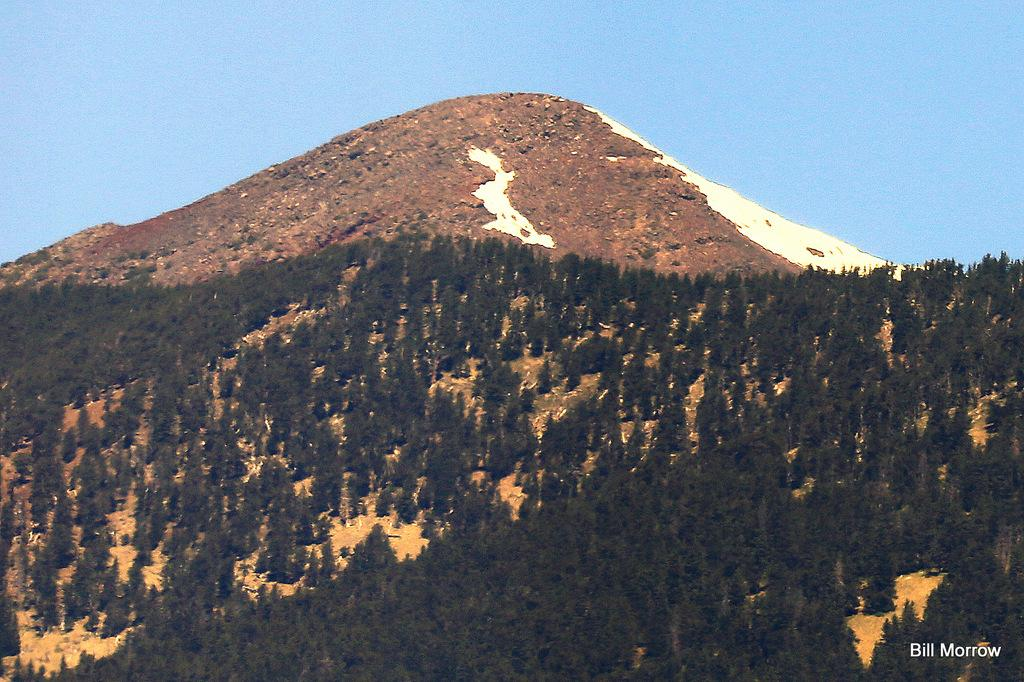What type of vegetation can be seen in the image? There are trees on a hill in the image. What is visible at the top of the image? The sky is visible at the top of the image. How many eggs are present in the image? There are no eggs visible in the image. What type of bubble can be seen in the image? There is no bubble present in the image. 